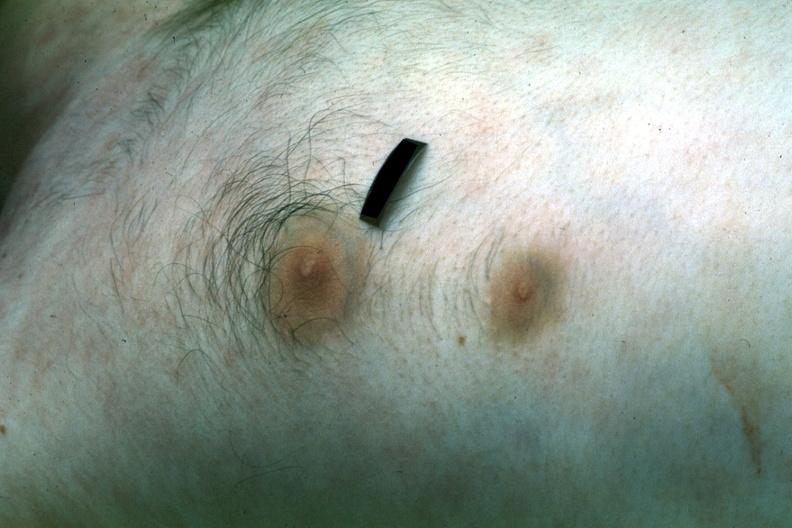s stillborn macerated present?
Answer the question using a single word or phrase. No 